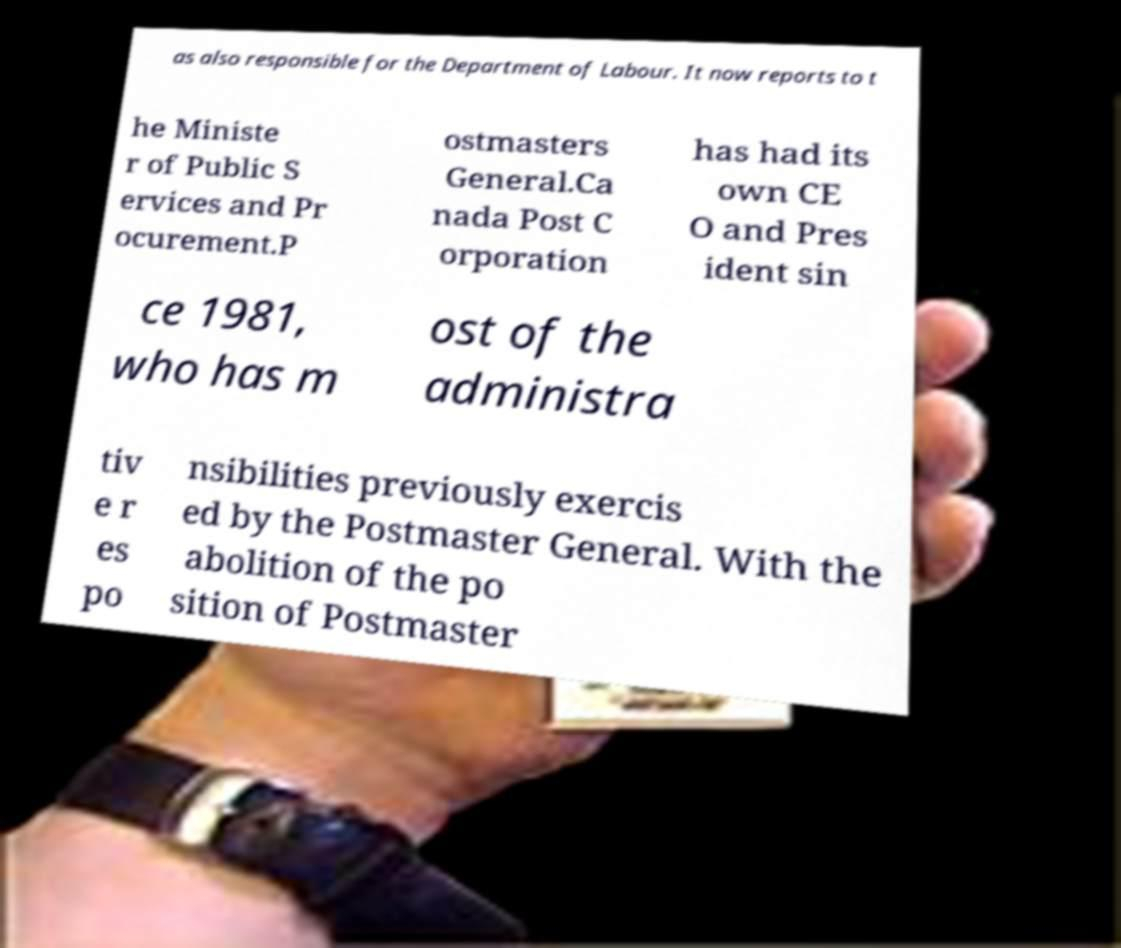Can you read and provide the text displayed in the image?This photo seems to have some interesting text. Can you extract and type it out for me? as also responsible for the Department of Labour. It now reports to t he Ministe r of Public S ervices and Pr ocurement.P ostmasters General.Ca nada Post C orporation has had its own CE O and Pres ident sin ce 1981, who has m ost of the administra tiv e r es po nsibilities previously exercis ed by the Postmaster General. With the abolition of the po sition of Postmaster 